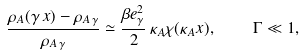<formula> <loc_0><loc_0><loc_500><loc_500>\frac { \rho _ { A } ( \gamma \, x ) - \rho _ { A \, \gamma } } { \rho _ { A \, \gamma } } \simeq \frac { \beta e _ { \gamma } ^ { 2 } } { 2 } \, \kappa _ { A } \chi ( \kappa _ { A } x ) , \quad \Gamma \ll 1 ,</formula> 